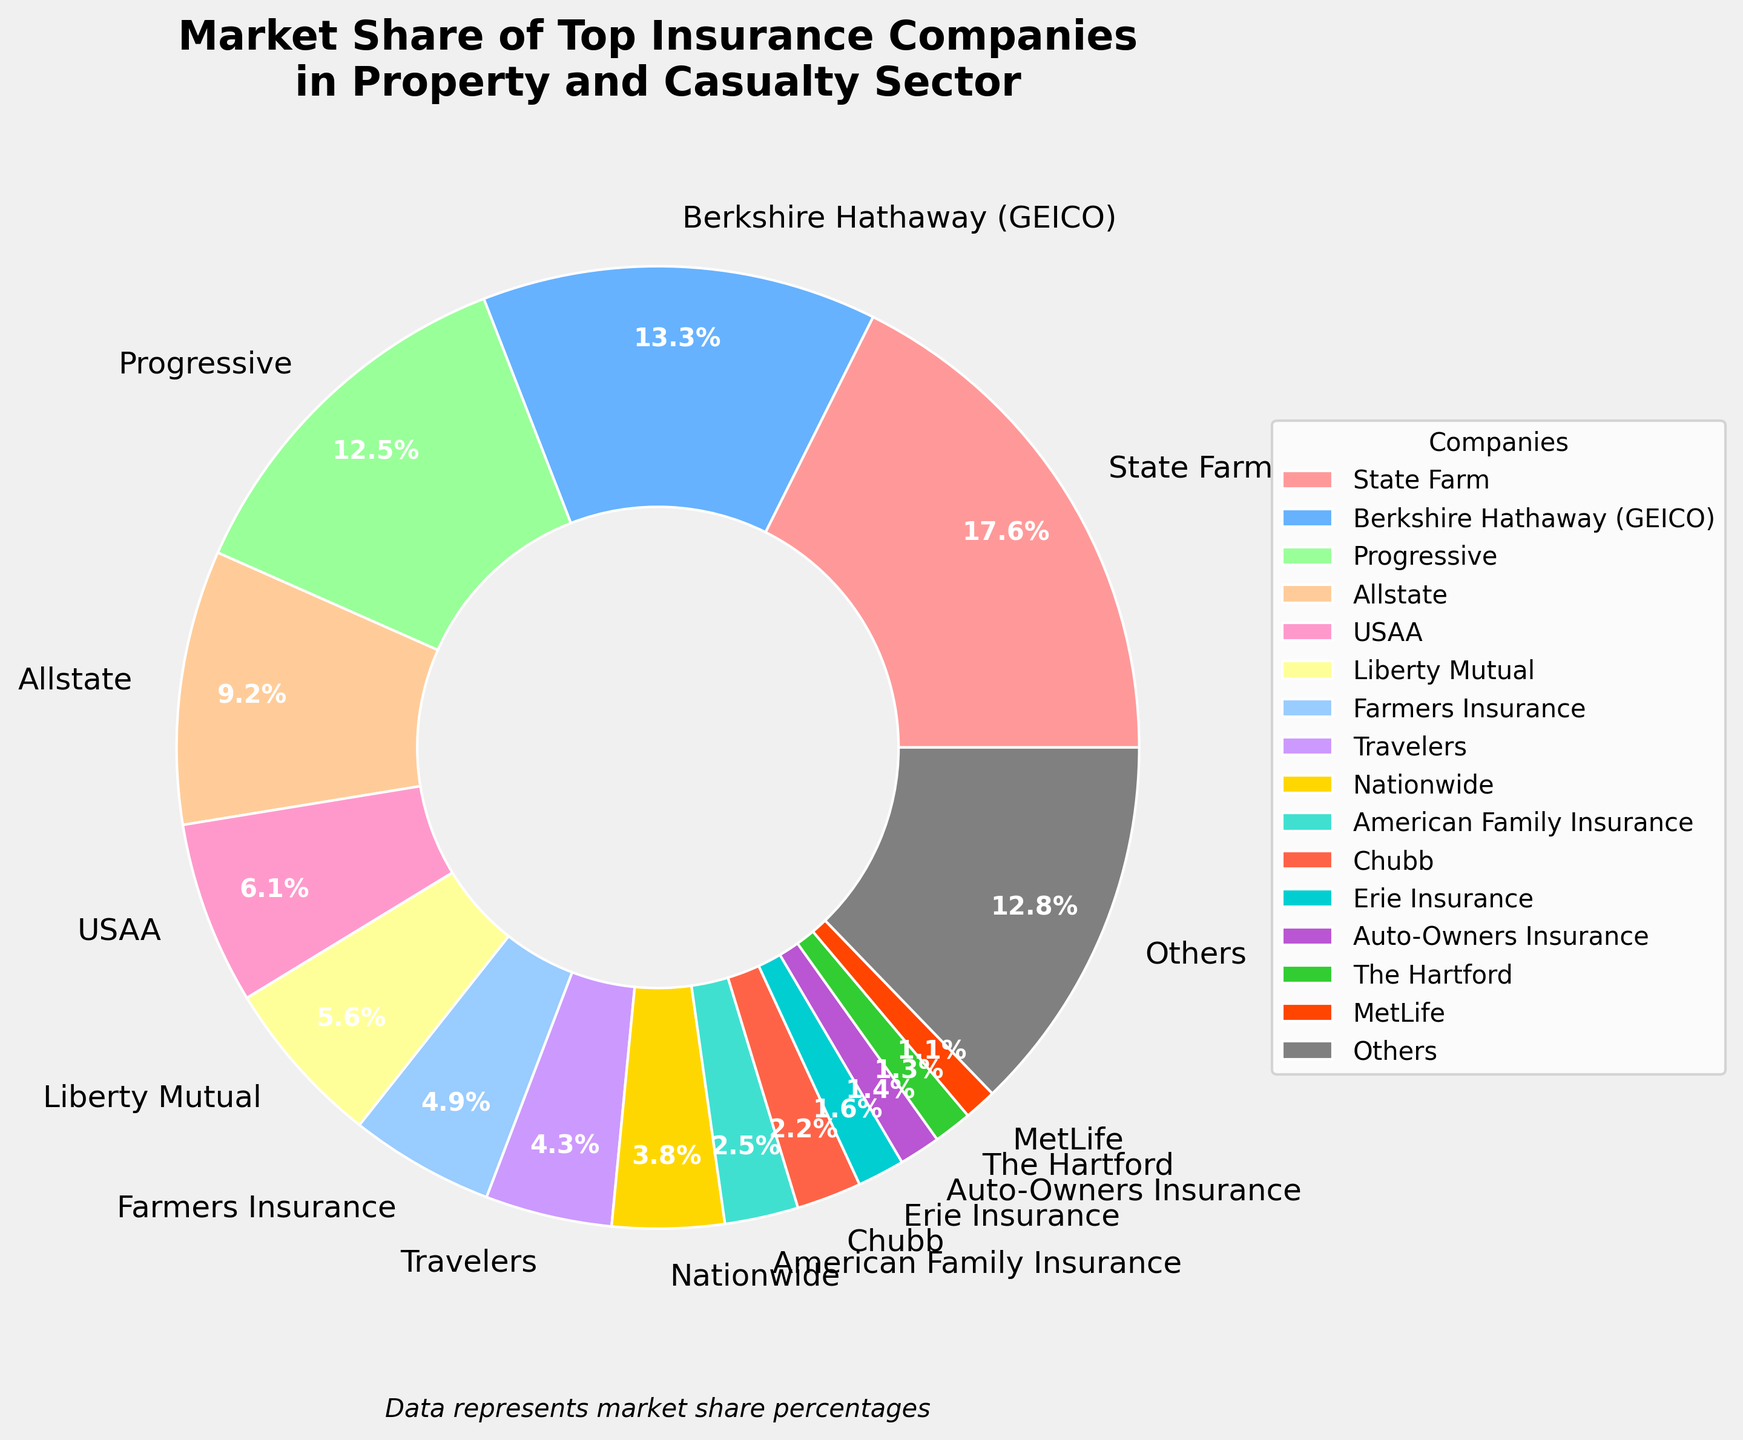Which company holds the largest market share in the property and casualty sector? The pie chart shows different slices representing market shares of companies. The largest slice represents State Farm with a 17.8% market share.
Answer: State Farm Which company has a greater market share, USAA or Liberty Mutual? USAA has a market share of 6.2%, while Liberty Mutual has a market share of 5.7%. Comparing these numbers, USAA has a greater market share.
Answer: USAA What is the combined market share of Progressive and Allstate? Progressive has a market share of 12.6% and Allstate has a market share of 9.3%. Summing these up, 12.6% + 9.3% = 21.9%.
Answer: 21.9% How much larger is State Farm's market share compared to American Family Insurance? State Farm has a market share of 17.8% and American Family Insurance has 2.5%. Subtracting these, 17.8% - 2.5% = 15.3%.
Answer: 15.3% Which color represents Berkshire Hathaway (GEICO) in the pie chart? In the pie chart, Berkshire Hathaway (GEICO) is represented by the second slice, which is colored blue.
Answer: Blue Is the market share of 'Others' segment higher than Farmers Insurance? The market share for 'Others' is 12.9%, while Farmers Insurance has a market share of 4.9%. Comparing these numbers, 'Others' has a higher market share.
Answer: Yes Excluding State Farm, what is the average market share of the remaining companies (including 'Others')? Excluding State Farm (17.8%), the remaining companies' market shares sum up to 82.2% for 15 companies. Average = 82.2 / 15 ≈ 5.48%.
Answer: 5.48% Identify three companies with the smallest market shares and their combined total. The three companies with the smallest market shares are MetLife (1.1%), The Hartford (1.3%), and Auto-Owners Insurance (1.4%). Summing these up, 1.1% + 1.3% + 1.4% = 3.8%.
Answer: 3.8% What percentage does the top three companies collectively contribute to the market share? State Farm (17.8%), Berkshire Hathaway (13.4%), and Progressive (12.6%) are the top three. Summing these up, 17.8% + 13.4% + 12.6% = 43.8%.
Answer: 43.8% Between Erie Insurance and Travelers, which company holds a smaller market share? Erie Insurance has a market share of 1.6%, while Travelers has a market share of 4.3%. Comparing these numbers, Erie Insurance holds a smaller market share.
Answer: Erie Insurance 